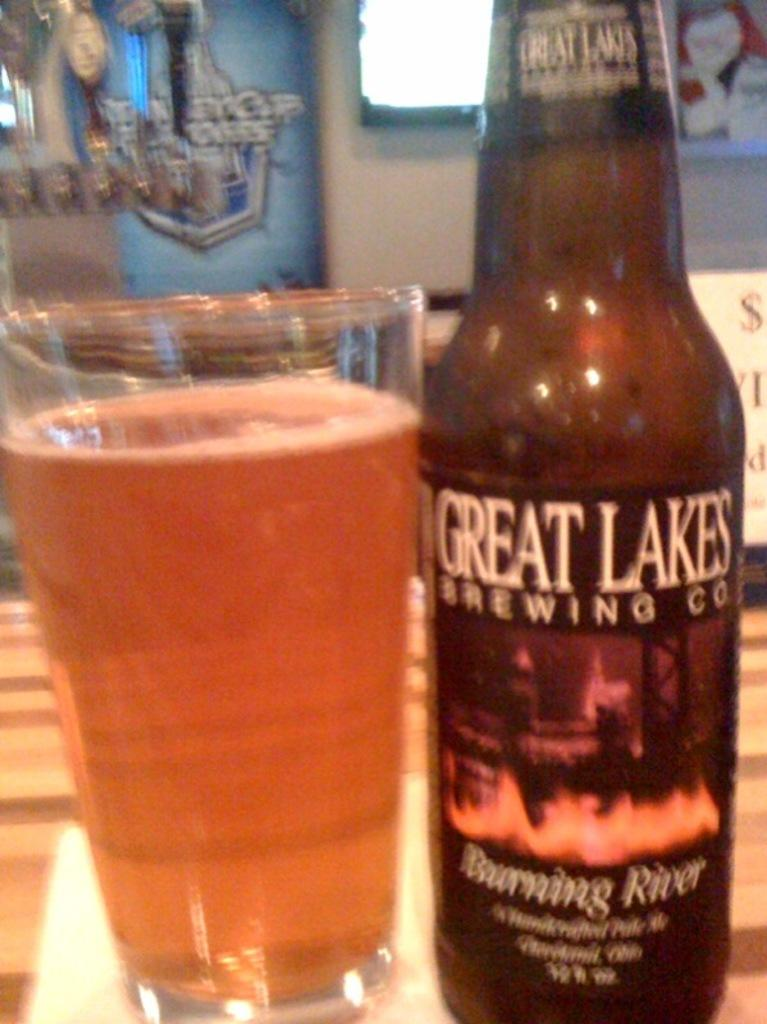<image>
Present a compact description of the photo's key features. a bottle of great lakes brewing co burning river 